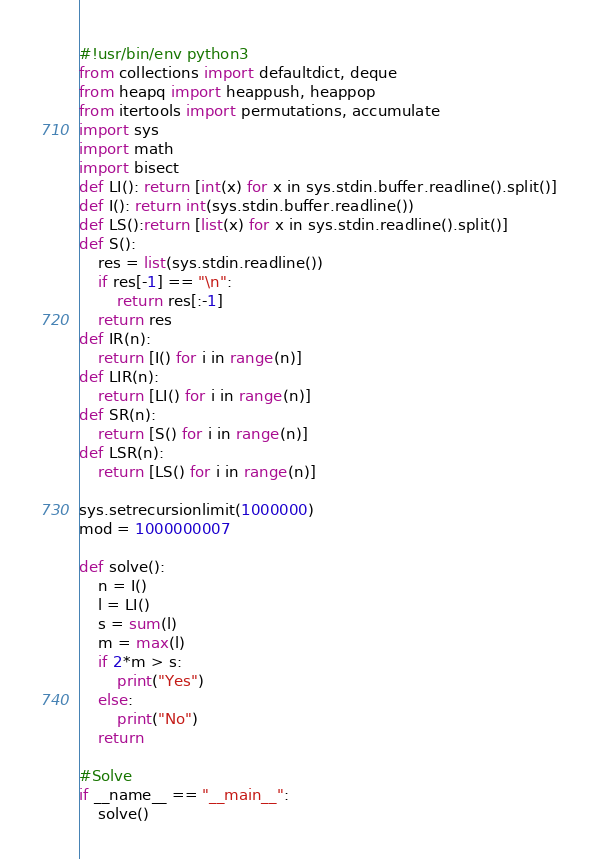<code> <loc_0><loc_0><loc_500><loc_500><_Python_>#!usr/bin/env python3
from collections import defaultdict, deque
from heapq import heappush, heappop
from itertools import permutations, accumulate
import sys
import math
import bisect
def LI(): return [int(x) for x in sys.stdin.buffer.readline().split()]
def I(): return int(sys.stdin.buffer.readline())
def LS():return [list(x) for x in sys.stdin.readline().split()]
def S():
    res = list(sys.stdin.readline())
    if res[-1] == "\n":
        return res[:-1]
    return res
def IR(n):
    return [I() for i in range(n)]
def LIR(n):
    return [LI() for i in range(n)]
def SR(n):
    return [S() for i in range(n)]
def LSR(n):
    return [LS() for i in range(n)]

sys.setrecursionlimit(1000000)
mod = 1000000007

def solve():
    n = I()
    l = LI()
    s = sum(l)
    m = max(l)
    if 2*m > s:
        print("Yes")
    else:
        print("No")
    return

#Solve
if __name__ == "__main__":
    solve()
</code> 